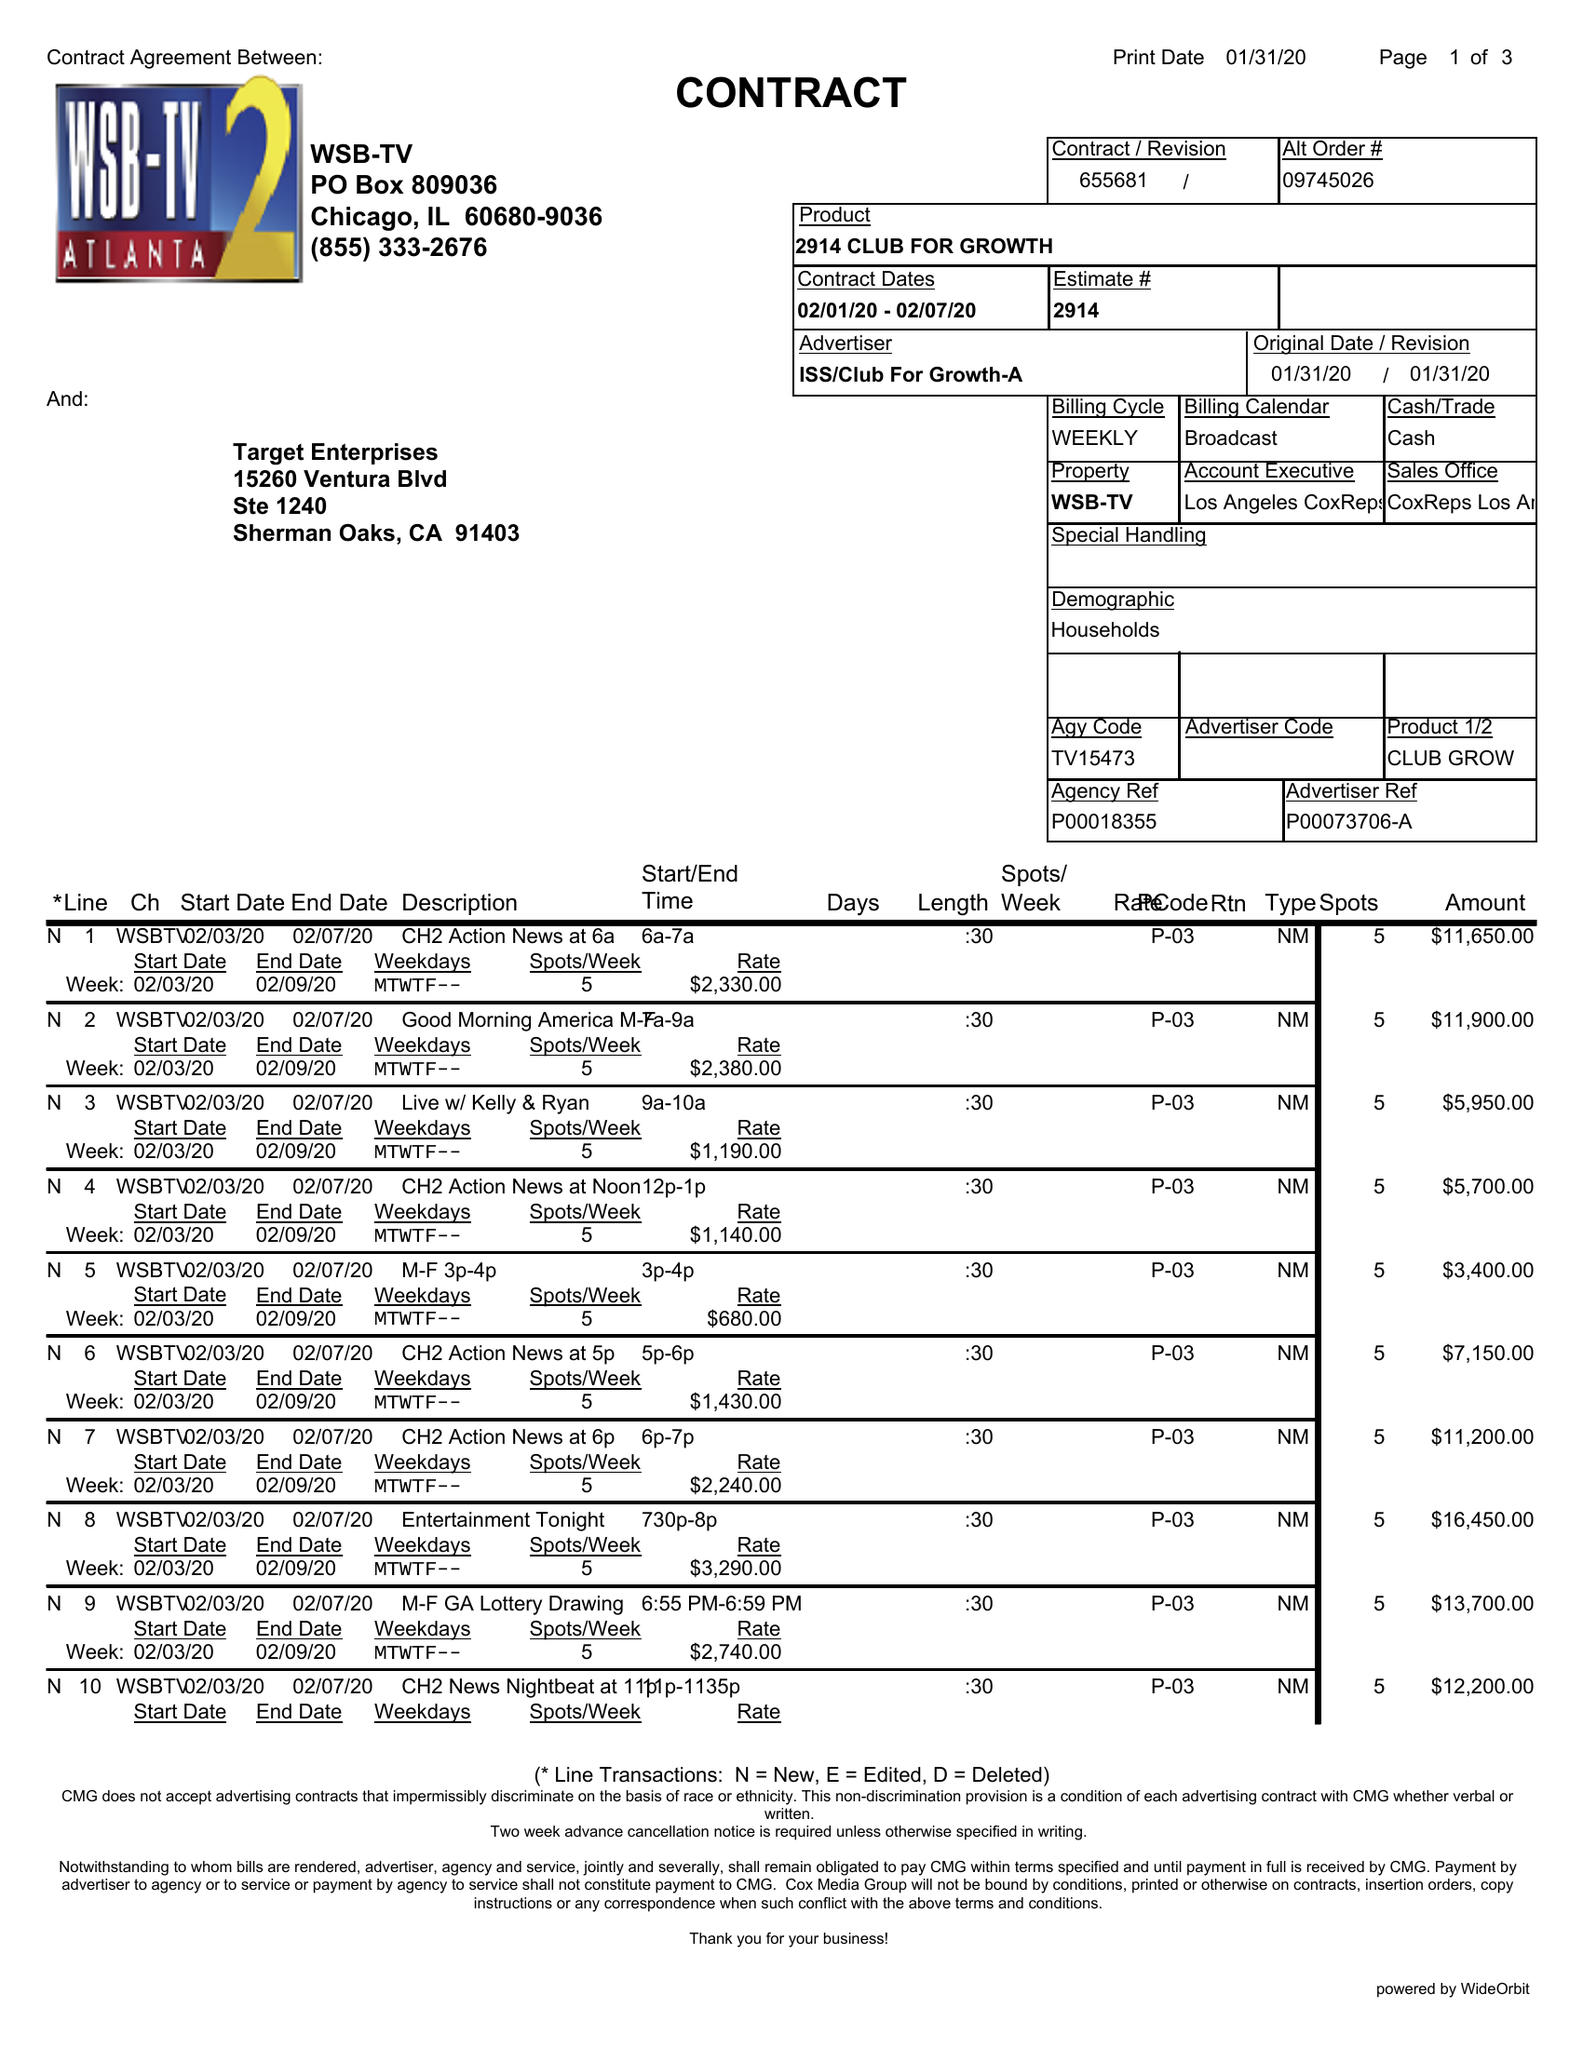What is the value for the flight_to?
Answer the question using a single word or phrase. 02/07/20 